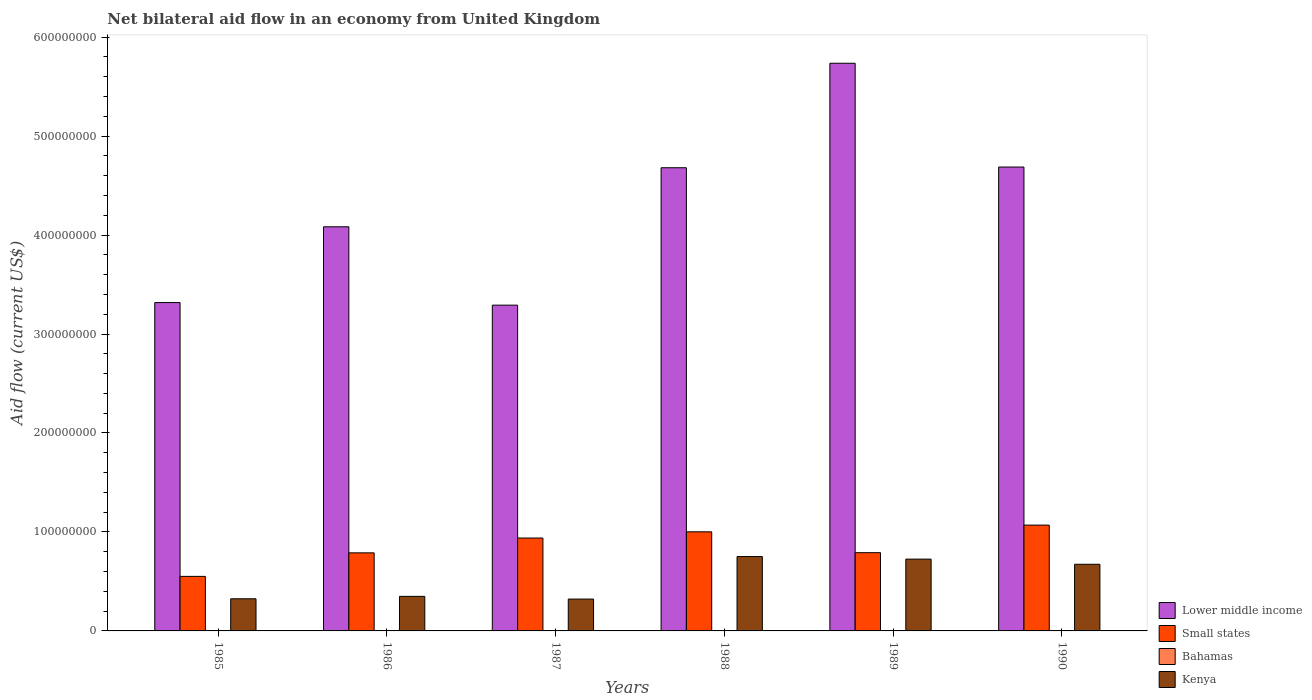How many different coloured bars are there?
Your answer should be very brief. 4. How many bars are there on the 6th tick from the right?
Keep it short and to the point. 4. What is the net bilateral aid flow in Kenya in 1988?
Provide a short and direct response. 7.51e+07. Across all years, what is the maximum net bilateral aid flow in Kenya?
Keep it short and to the point. 7.51e+07. Across all years, what is the minimum net bilateral aid flow in Small states?
Keep it short and to the point. 5.51e+07. In which year was the net bilateral aid flow in Kenya minimum?
Your answer should be compact. 1987. What is the total net bilateral aid flow in Small states in the graph?
Provide a short and direct response. 5.14e+08. What is the difference between the net bilateral aid flow in Lower middle income in 1985 and the net bilateral aid flow in Small states in 1990?
Provide a succinct answer. 2.25e+08. What is the average net bilateral aid flow in Lower middle income per year?
Provide a short and direct response. 4.30e+08. In the year 1988, what is the difference between the net bilateral aid flow in Bahamas and net bilateral aid flow in Small states?
Make the answer very short. -1.00e+08. What is the ratio of the net bilateral aid flow in Lower middle income in 1986 to that in 1987?
Ensure brevity in your answer.  1.24. What is the difference between the highest and the second highest net bilateral aid flow in Lower middle income?
Give a very brief answer. 1.05e+08. What is the difference between the highest and the lowest net bilateral aid flow in Kenya?
Provide a short and direct response. 4.29e+07. In how many years, is the net bilateral aid flow in Small states greater than the average net bilateral aid flow in Small states taken over all years?
Your answer should be compact. 3. Is the sum of the net bilateral aid flow in Lower middle income in 1986 and 1990 greater than the maximum net bilateral aid flow in Small states across all years?
Provide a short and direct response. Yes. What does the 2nd bar from the left in 1989 represents?
Your response must be concise. Small states. What does the 4th bar from the right in 1985 represents?
Give a very brief answer. Lower middle income. Are the values on the major ticks of Y-axis written in scientific E-notation?
Provide a succinct answer. No. Does the graph contain grids?
Your answer should be very brief. No. Where does the legend appear in the graph?
Ensure brevity in your answer.  Bottom right. What is the title of the graph?
Offer a terse response. Net bilateral aid flow in an economy from United Kingdom. What is the label or title of the X-axis?
Your answer should be compact. Years. What is the label or title of the Y-axis?
Keep it short and to the point. Aid flow (current US$). What is the Aid flow (current US$) of Lower middle income in 1985?
Offer a very short reply. 3.32e+08. What is the Aid flow (current US$) of Small states in 1985?
Your response must be concise. 5.51e+07. What is the Aid flow (current US$) in Bahamas in 1985?
Your answer should be very brief. 10000. What is the Aid flow (current US$) in Kenya in 1985?
Your answer should be very brief. 3.25e+07. What is the Aid flow (current US$) of Lower middle income in 1986?
Provide a short and direct response. 4.08e+08. What is the Aid flow (current US$) of Small states in 1986?
Give a very brief answer. 7.89e+07. What is the Aid flow (current US$) in Bahamas in 1986?
Offer a very short reply. 10000. What is the Aid flow (current US$) in Kenya in 1986?
Provide a short and direct response. 3.49e+07. What is the Aid flow (current US$) in Lower middle income in 1987?
Keep it short and to the point. 3.29e+08. What is the Aid flow (current US$) in Small states in 1987?
Ensure brevity in your answer.  9.39e+07. What is the Aid flow (current US$) of Kenya in 1987?
Offer a terse response. 3.22e+07. What is the Aid flow (current US$) in Lower middle income in 1988?
Give a very brief answer. 4.68e+08. What is the Aid flow (current US$) in Small states in 1988?
Your answer should be very brief. 1.00e+08. What is the Aid flow (current US$) of Kenya in 1988?
Give a very brief answer. 7.51e+07. What is the Aid flow (current US$) in Lower middle income in 1989?
Offer a very short reply. 5.74e+08. What is the Aid flow (current US$) in Small states in 1989?
Make the answer very short. 7.91e+07. What is the Aid flow (current US$) of Bahamas in 1989?
Your answer should be compact. 3.00e+04. What is the Aid flow (current US$) in Kenya in 1989?
Provide a succinct answer. 7.26e+07. What is the Aid flow (current US$) in Lower middle income in 1990?
Make the answer very short. 4.69e+08. What is the Aid flow (current US$) in Small states in 1990?
Ensure brevity in your answer.  1.07e+08. What is the Aid flow (current US$) in Kenya in 1990?
Offer a terse response. 6.73e+07. Across all years, what is the maximum Aid flow (current US$) in Lower middle income?
Ensure brevity in your answer.  5.74e+08. Across all years, what is the maximum Aid flow (current US$) of Small states?
Provide a short and direct response. 1.07e+08. Across all years, what is the maximum Aid flow (current US$) of Kenya?
Offer a terse response. 7.51e+07. Across all years, what is the minimum Aid flow (current US$) of Lower middle income?
Keep it short and to the point. 3.29e+08. Across all years, what is the minimum Aid flow (current US$) in Small states?
Your answer should be compact. 5.51e+07. Across all years, what is the minimum Aid flow (current US$) in Kenya?
Offer a very short reply. 3.22e+07. What is the total Aid flow (current US$) in Lower middle income in the graph?
Make the answer very short. 2.58e+09. What is the total Aid flow (current US$) of Small states in the graph?
Offer a terse response. 5.14e+08. What is the total Aid flow (current US$) in Kenya in the graph?
Your answer should be compact. 3.15e+08. What is the difference between the Aid flow (current US$) in Lower middle income in 1985 and that in 1986?
Offer a terse response. -7.66e+07. What is the difference between the Aid flow (current US$) of Small states in 1985 and that in 1986?
Offer a very short reply. -2.38e+07. What is the difference between the Aid flow (current US$) of Kenya in 1985 and that in 1986?
Offer a very short reply. -2.45e+06. What is the difference between the Aid flow (current US$) of Lower middle income in 1985 and that in 1987?
Make the answer very short. 2.61e+06. What is the difference between the Aid flow (current US$) in Small states in 1985 and that in 1987?
Give a very brief answer. -3.88e+07. What is the difference between the Aid flow (current US$) in Kenya in 1985 and that in 1987?
Your response must be concise. 2.90e+05. What is the difference between the Aid flow (current US$) in Lower middle income in 1985 and that in 1988?
Offer a terse response. -1.36e+08. What is the difference between the Aid flow (current US$) in Small states in 1985 and that in 1988?
Give a very brief answer. -4.50e+07. What is the difference between the Aid flow (current US$) in Kenya in 1985 and that in 1988?
Offer a very short reply. -4.26e+07. What is the difference between the Aid flow (current US$) of Lower middle income in 1985 and that in 1989?
Offer a very short reply. -2.42e+08. What is the difference between the Aid flow (current US$) of Small states in 1985 and that in 1989?
Ensure brevity in your answer.  -2.40e+07. What is the difference between the Aid flow (current US$) in Bahamas in 1985 and that in 1989?
Keep it short and to the point. -2.00e+04. What is the difference between the Aid flow (current US$) of Kenya in 1985 and that in 1989?
Your answer should be compact. -4.01e+07. What is the difference between the Aid flow (current US$) in Lower middle income in 1985 and that in 1990?
Keep it short and to the point. -1.37e+08. What is the difference between the Aid flow (current US$) in Small states in 1985 and that in 1990?
Your answer should be very brief. -5.18e+07. What is the difference between the Aid flow (current US$) in Bahamas in 1985 and that in 1990?
Offer a very short reply. -1.30e+05. What is the difference between the Aid flow (current US$) of Kenya in 1985 and that in 1990?
Provide a succinct answer. -3.49e+07. What is the difference between the Aid flow (current US$) in Lower middle income in 1986 and that in 1987?
Your answer should be compact. 7.92e+07. What is the difference between the Aid flow (current US$) of Small states in 1986 and that in 1987?
Keep it short and to the point. -1.50e+07. What is the difference between the Aid flow (current US$) of Kenya in 1986 and that in 1987?
Provide a succinct answer. 2.74e+06. What is the difference between the Aid flow (current US$) of Lower middle income in 1986 and that in 1988?
Your response must be concise. -5.96e+07. What is the difference between the Aid flow (current US$) of Small states in 1986 and that in 1988?
Offer a terse response. -2.12e+07. What is the difference between the Aid flow (current US$) of Bahamas in 1986 and that in 1988?
Ensure brevity in your answer.  0. What is the difference between the Aid flow (current US$) in Kenya in 1986 and that in 1988?
Your response must be concise. -4.02e+07. What is the difference between the Aid flow (current US$) in Lower middle income in 1986 and that in 1989?
Offer a terse response. -1.65e+08. What is the difference between the Aid flow (current US$) in Small states in 1986 and that in 1989?
Offer a very short reply. -1.70e+05. What is the difference between the Aid flow (current US$) in Kenya in 1986 and that in 1989?
Make the answer very short. -3.76e+07. What is the difference between the Aid flow (current US$) of Lower middle income in 1986 and that in 1990?
Offer a terse response. -6.04e+07. What is the difference between the Aid flow (current US$) in Small states in 1986 and that in 1990?
Give a very brief answer. -2.80e+07. What is the difference between the Aid flow (current US$) of Bahamas in 1986 and that in 1990?
Your answer should be very brief. -1.30e+05. What is the difference between the Aid flow (current US$) in Kenya in 1986 and that in 1990?
Give a very brief answer. -3.24e+07. What is the difference between the Aid flow (current US$) in Lower middle income in 1987 and that in 1988?
Offer a very short reply. -1.39e+08. What is the difference between the Aid flow (current US$) in Small states in 1987 and that in 1988?
Your answer should be compact. -6.27e+06. What is the difference between the Aid flow (current US$) in Kenya in 1987 and that in 1988?
Keep it short and to the point. -4.29e+07. What is the difference between the Aid flow (current US$) in Lower middle income in 1987 and that in 1989?
Your answer should be very brief. -2.44e+08. What is the difference between the Aid flow (current US$) of Small states in 1987 and that in 1989?
Give a very brief answer. 1.48e+07. What is the difference between the Aid flow (current US$) in Kenya in 1987 and that in 1989?
Offer a very short reply. -4.04e+07. What is the difference between the Aid flow (current US$) in Lower middle income in 1987 and that in 1990?
Ensure brevity in your answer.  -1.40e+08. What is the difference between the Aid flow (current US$) of Small states in 1987 and that in 1990?
Provide a succinct answer. -1.31e+07. What is the difference between the Aid flow (current US$) of Bahamas in 1987 and that in 1990?
Provide a short and direct response. -1.20e+05. What is the difference between the Aid flow (current US$) of Kenya in 1987 and that in 1990?
Your answer should be very brief. -3.52e+07. What is the difference between the Aid flow (current US$) of Lower middle income in 1988 and that in 1989?
Keep it short and to the point. -1.06e+08. What is the difference between the Aid flow (current US$) of Small states in 1988 and that in 1989?
Ensure brevity in your answer.  2.11e+07. What is the difference between the Aid flow (current US$) in Bahamas in 1988 and that in 1989?
Provide a short and direct response. -2.00e+04. What is the difference between the Aid flow (current US$) of Kenya in 1988 and that in 1989?
Offer a terse response. 2.56e+06. What is the difference between the Aid flow (current US$) in Lower middle income in 1988 and that in 1990?
Make the answer very short. -7.00e+05. What is the difference between the Aid flow (current US$) in Small states in 1988 and that in 1990?
Provide a short and direct response. -6.79e+06. What is the difference between the Aid flow (current US$) in Kenya in 1988 and that in 1990?
Offer a terse response. 7.78e+06. What is the difference between the Aid flow (current US$) of Lower middle income in 1989 and that in 1990?
Give a very brief answer. 1.05e+08. What is the difference between the Aid flow (current US$) in Small states in 1989 and that in 1990?
Your answer should be compact. -2.79e+07. What is the difference between the Aid flow (current US$) of Bahamas in 1989 and that in 1990?
Your answer should be very brief. -1.10e+05. What is the difference between the Aid flow (current US$) in Kenya in 1989 and that in 1990?
Keep it short and to the point. 5.22e+06. What is the difference between the Aid flow (current US$) in Lower middle income in 1985 and the Aid flow (current US$) in Small states in 1986?
Your answer should be compact. 2.53e+08. What is the difference between the Aid flow (current US$) of Lower middle income in 1985 and the Aid flow (current US$) of Bahamas in 1986?
Your answer should be compact. 3.32e+08. What is the difference between the Aid flow (current US$) in Lower middle income in 1985 and the Aid flow (current US$) in Kenya in 1986?
Your answer should be compact. 2.97e+08. What is the difference between the Aid flow (current US$) in Small states in 1985 and the Aid flow (current US$) in Bahamas in 1986?
Your response must be concise. 5.51e+07. What is the difference between the Aid flow (current US$) in Small states in 1985 and the Aid flow (current US$) in Kenya in 1986?
Keep it short and to the point. 2.02e+07. What is the difference between the Aid flow (current US$) in Bahamas in 1985 and the Aid flow (current US$) in Kenya in 1986?
Your answer should be compact. -3.49e+07. What is the difference between the Aid flow (current US$) of Lower middle income in 1985 and the Aid flow (current US$) of Small states in 1987?
Your answer should be compact. 2.38e+08. What is the difference between the Aid flow (current US$) in Lower middle income in 1985 and the Aid flow (current US$) in Bahamas in 1987?
Your response must be concise. 3.32e+08. What is the difference between the Aid flow (current US$) in Lower middle income in 1985 and the Aid flow (current US$) in Kenya in 1987?
Your answer should be compact. 3.00e+08. What is the difference between the Aid flow (current US$) of Small states in 1985 and the Aid flow (current US$) of Bahamas in 1987?
Your answer should be compact. 5.51e+07. What is the difference between the Aid flow (current US$) in Small states in 1985 and the Aid flow (current US$) in Kenya in 1987?
Make the answer very short. 2.29e+07. What is the difference between the Aid flow (current US$) in Bahamas in 1985 and the Aid flow (current US$) in Kenya in 1987?
Provide a short and direct response. -3.22e+07. What is the difference between the Aid flow (current US$) of Lower middle income in 1985 and the Aid flow (current US$) of Small states in 1988?
Your answer should be compact. 2.32e+08. What is the difference between the Aid flow (current US$) in Lower middle income in 1985 and the Aid flow (current US$) in Bahamas in 1988?
Give a very brief answer. 3.32e+08. What is the difference between the Aid flow (current US$) in Lower middle income in 1985 and the Aid flow (current US$) in Kenya in 1988?
Keep it short and to the point. 2.57e+08. What is the difference between the Aid flow (current US$) in Small states in 1985 and the Aid flow (current US$) in Bahamas in 1988?
Give a very brief answer. 5.51e+07. What is the difference between the Aid flow (current US$) in Small states in 1985 and the Aid flow (current US$) in Kenya in 1988?
Offer a terse response. -2.00e+07. What is the difference between the Aid flow (current US$) of Bahamas in 1985 and the Aid flow (current US$) of Kenya in 1988?
Provide a succinct answer. -7.51e+07. What is the difference between the Aid flow (current US$) of Lower middle income in 1985 and the Aid flow (current US$) of Small states in 1989?
Offer a very short reply. 2.53e+08. What is the difference between the Aid flow (current US$) of Lower middle income in 1985 and the Aid flow (current US$) of Bahamas in 1989?
Provide a succinct answer. 3.32e+08. What is the difference between the Aid flow (current US$) in Lower middle income in 1985 and the Aid flow (current US$) in Kenya in 1989?
Provide a short and direct response. 2.59e+08. What is the difference between the Aid flow (current US$) of Small states in 1985 and the Aid flow (current US$) of Bahamas in 1989?
Your answer should be compact. 5.51e+07. What is the difference between the Aid flow (current US$) in Small states in 1985 and the Aid flow (current US$) in Kenya in 1989?
Give a very brief answer. -1.75e+07. What is the difference between the Aid flow (current US$) of Bahamas in 1985 and the Aid flow (current US$) of Kenya in 1989?
Your answer should be very brief. -7.26e+07. What is the difference between the Aid flow (current US$) in Lower middle income in 1985 and the Aid flow (current US$) in Small states in 1990?
Your response must be concise. 2.25e+08. What is the difference between the Aid flow (current US$) in Lower middle income in 1985 and the Aid flow (current US$) in Bahamas in 1990?
Offer a very short reply. 3.32e+08. What is the difference between the Aid flow (current US$) of Lower middle income in 1985 and the Aid flow (current US$) of Kenya in 1990?
Your response must be concise. 2.64e+08. What is the difference between the Aid flow (current US$) in Small states in 1985 and the Aid flow (current US$) in Bahamas in 1990?
Offer a terse response. 5.50e+07. What is the difference between the Aid flow (current US$) in Small states in 1985 and the Aid flow (current US$) in Kenya in 1990?
Your answer should be compact. -1.22e+07. What is the difference between the Aid flow (current US$) of Bahamas in 1985 and the Aid flow (current US$) of Kenya in 1990?
Your response must be concise. -6.73e+07. What is the difference between the Aid flow (current US$) in Lower middle income in 1986 and the Aid flow (current US$) in Small states in 1987?
Give a very brief answer. 3.14e+08. What is the difference between the Aid flow (current US$) of Lower middle income in 1986 and the Aid flow (current US$) of Bahamas in 1987?
Your answer should be compact. 4.08e+08. What is the difference between the Aid flow (current US$) in Lower middle income in 1986 and the Aid flow (current US$) in Kenya in 1987?
Your answer should be very brief. 3.76e+08. What is the difference between the Aid flow (current US$) in Small states in 1986 and the Aid flow (current US$) in Bahamas in 1987?
Offer a terse response. 7.89e+07. What is the difference between the Aid flow (current US$) in Small states in 1986 and the Aid flow (current US$) in Kenya in 1987?
Give a very brief answer. 4.67e+07. What is the difference between the Aid flow (current US$) of Bahamas in 1986 and the Aid flow (current US$) of Kenya in 1987?
Offer a very short reply. -3.22e+07. What is the difference between the Aid flow (current US$) in Lower middle income in 1986 and the Aid flow (current US$) in Small states in 1988?
Your response must be concise. 3.08e+08. What is the difference between the Aid flow (current US$) of Lower middle income in 1986 and the Aid flow (current US$) of Bahamas in 1988?
Your answer should be very brief. 4.08e+08. What is the difference between the Aid flow (current US$) of Lower middle income in 1986 and the Aid flow (current US$) of Kenya in 1988?
Your answer should be very brief. 3.33e+08. What is the difference between the Aid flow (current US$) of Small states in 1986 and the Aid flow (current US$) of Bahamas in 1988?
Your answer should be compact. 7.89e+07. What is the difference between the Aid flow (current US$) in Small states in 1986 and the Aid flow (current US$) in Kenya in 1988?
Make the answer very short. 3.77e+06. What is the difference between the Aid flow (current US$) in Bahamas in 1986 and the Aid flow (current US$) in Kenya in 1988?
Make the answer very short. -7.51e+07. What is the difference between the Aid flow (current US$) of Lower middle income in 1986 and the Aid flow (current US$) of Small states in 1989?
Give a very brief answer. 3.29e+08. What is the difference between the Aid flow (current US$) of Lower middle income in 1986 and the Aid flow (current US$) of Bahamas in 1989?
Ensure brevity in your answer.  4.08e+08. What is the difference between the Aid flow (current US$) of Lower middle income in 1986 and the Aid flow (current US$) of Kenya in 1989?
Offer a very short reply. 3.36e+08. What is the difference between the Aid flow (current US$) of Small states in 1986 and the Aid flow (current US$) of Bahamas in 1989?
Your answer should be compact. 7.89e+07. What is the difference between the Aid flow (current US$) in Small states in 1986 and the Aid flow (current US$) in Kenya in 1989?
Your answer should be very brief. 6.33e+06. What is the difference between the Aid flow (current US$) in Bahamas in 1986 and the Aid flow (current US$) in Kenya in 1989?
Your answer should be very brief. -7.26e+07. What is the difference between the Aid flow (current US$) in Lower middle income in 1986 and the Aid flow (current US$) in Small states in 1990?
Make the answer very short. 3.01e+08. What is the difference between the Aid flow (current US$) of Lower middle income in 1986 and the Aid flow (current US$) of Bahamas in 1990?
Give a very brief answer. 4.08e+08. What is the difference between the Aid flow (current US$) of Lower middle income in 1986 and the Aid flow (current US$) of Kenya in 1990?
Make the answer very short. 3.41e+08. What is the difference between the Aid flow (current US$) in Small states in 1986 and the Aid flow (current US$) in Bahamas in 1990?
Make the answer very short. 7.88e+07. What is the difference between the Aid flow (current US$) in Small states in 1986 and the Aid flow (current US$) in Kenya in 1990?
Ensure brevity in your answer.  1.16e+07. What is the difference between the Aid flow (current US$) of Bahamas in 1986 and the Aid flow (current US$) of Kenya in 1990?
Your answer should be very brief. -6.73e+07. What is the difference between the Aid flow (current US$) of Lower middle income in 1987 and the Aid flow (current US$) of Small states in 1988?
Ensure brevity in your answer.  2.29e+08. What is the difference between the Aid flow (current US$) of Lower middle income in 1987 and the Aid flow (current US$) of Bahamas in 1988?
Offer a terse response. 3.29e+08. What is the difference between the Aid flow (current US$) of Lower middle income in 1987 and the Aid flow (current US$) of Kenya in 1988?
Provide a succinct answer. 2.54e+08. What is the difference between the Aid flow (current US$) of Small states in 1987 and the Aid flow (current US$) of Bahamas in 1988?
Your answer should be very brief. 9.38e+07. What is the difference between the Aid flow (current US$) in Small states in 1987 and the Aid flow (current US$) in Kenya in 1988?
Keep it short and to the point. 1.87e+07. What is the difference between the Aid flow (current US$) in Bahamas in 1987 and the Aid flow (current US$) in Kenya in 1988?
Offer a terse response. -7.51e+07. What is the difference between the Aid flow (current US$) in Lower middle income in 1987 and the Aid flow (current US$) in Small states in 1989?
Offer a very short reply. 2.50e+08. What is the difference between the Aid flow (current US$) of Lower middle income in 1987 and the Aid flow (current US$) of Bahamas in 1989?
Your response must be concise. 3.29e+08. What is the difference between the Aid flow (current US$) of Lower middle income in 1987 and the Aid flow (current US$) of Kenya in 1989?
Your answer should be very brief. 2.57e+08. What is the difference between the Aid flow (current US$) of Small states in 1987 and the Aid flow (current US$) of Bahamas in 1989?
Offer a terse response. 9.38e+07. What is the difference between the Aid flow (current US$) of Small states in 1987 and the Aid flow (current US$) of Kenya in 1989?
Your answer should be very brief. 2.13e+07. What is the difference between the Aid flow (current US$) of Bahamas in 1987 and the Aid flow (current US$) of Kenya in 1989?
Your answer should be very brief. -7.25e+07. What is the difference between the Aid flow (current US$) in Lower middle income in 1987 and the Aid flow (current US$) in Small states in 1990?
Offer a very short reply. 2.22e+08. What is the difference between the Aid flow (current US$) of Lower middle income in 1987 and the Aid flow (current US$) of Bahamas in 1990?
Ensure brevity in your answer.  3.29e+08. What is the difference between the Aid flow (current US$) of Lower middle income in 1987 and the Aid flow (current US$) of Kenya in 1990?
Provide a short and direct response. 2.62e+08. What is the difference between the Aid flow (current US$) in Small states in 1987 and the Aid flow (current US$) in Bahamas in 1990?
Keep it short and to the point. 9.37e+07. What is the difference between the Aid flow (current US$) of Small states in 1987 and the Aid flow (current US$) of Kenya in 1990?
Your answer should be very brief. 2.65e+07. What is the difference between the Aid flow (current US$) in Bahamas in 1987 and the Aid flow (current US$) in Kenya in 1990?
Your answer should be compact. -6.73e+07. What is the difference between the Aid flow (current US$) of Lower middle income in 1988 and the Aid flow (current US$) of Small states in 1989?
Your answer should be very brief. 3.89e+08. What is the difference between the Aid flow (current US$) of Lower middle income in 1988 and the Aid flow (current US$) of Bahamas in 1989?
Your response must be concise. 4.68e+08. What is the difference between the Aid flow (current US$) of Lower middle income in 1988 and the Aid flow (current US$) of Kenya in 1989?
Your answer should be very brief. 3.95e+08. What is the difference between the Aid flow (current US$) in Small states in 1988 and the Aid flow (current US$) in Bahamas in 1989?
Your answer should be very brief. 1.00e+08. What is the difference between the Aid flow (current US$) of Small states in 1988 and the Aid flow (current US$) of Kenya in 1989?
Your answer should be compact. 2.76e+07. What is the difference between the Aid flow (current US$) in Bahamas in 1988 and the Aid flow (current US$) in Kenya in 1989?
Your answer should be compact. -7.26e+07. What is the difference between the Aid flow (current US$) in Lower middle income in 1988 and the Aid flow (current US$) in Small states in 1990?
Give a very brief answer. 3.61e+08. What is the difference between the Aid flow (current US$) of Lower middle income in 1988 and the Aid flow (current US$) of Bahamas in 1990?
Your response must be concise. 4.68e+08. What is the difference between the Aid flow (current US$) in Lower middle income in 1988 and the Aid flow (current US$) in Kenya in 1990?
Provide a succinct answer. 4.01e+08. What is the difference between the Aid flow (current US$) of Small states in 1988 and the Aid flow (current US$) of Bahamas in 1990?
Offer a terse response. 1.00e+08. What is the difference between the Aid flow (current US$) of Small states in 1988 and the Aid flow (current US$) of Kenya in 1990?
Make the answer very short. 3.28e+07. What is the difference between the Aid flow (current US$) of Bahamas in 1988 and the Aid flow (current US$) of Kenya in 1990?
Offer a very short reply. -6.73e+07. What is the difference between the Aid flow (current US$) in Lower middle income in 1989 and the Aid flow (current US$) in Small states in 1990?
Provide a succinct answer. 4.67e+08. What is the difference between the Aid flow (current US$) of Lower middle income in 1989 and the Aid flow (current US$) of Bahamas in 1990?
Your response must be concise. 5.73e+08. What is the difference between the Aid flow (current US$) in Lower middle income in 1989 and the Aid flow (current US$) in Kenya in 1990?
Offer a terse response. 5.06e+08. What is the difference between the Aid flow (current US$) of Small states in 1989 and the Aid flow (current US$) of Bahamas in 1990?
Ensure brevity in your answer.  7.89e+07. What is the difference between the Aid flow (current US$) in Small states in 1989 and the Aid flow (current US$) in Kenya in 1990?
Your answer should be very brief. 1.17e+07. What is the difference between the Aid flow (current US$) in Bahamas in 1989 and the Aid flow (current US$) in Kenya in 1990?
Provide a succinct answer. -6.73e+07. What is the average Aid flow (current US$) in Lower middle income per year?
Make the answer very short. 4.30e+08. What is the average Aid flow (current US$) of Small states per year?
Keep it short and to the point. 8.57e+07. What is the average Aid flow (current US$) of Bahamas per year?
Give a very brief answer. 3.67e+04. What is the average Aid flow (current US$) in Kenya per year?
Your response must be concise. 5.24e+07. In the year 1985, what is the difference between the Aid flow (current US$) of Lower middle income and Aid flow (current US$) of Small states?
Provide a short and direct response. 2.77e+08. In the year 1985, what is the difference between the Aid flow (current US$) in Lower middle income and Aid flow (current US$) in Bahamas?
Make the answer very short. 3.32e+08. In the year 1985, what is the difference between the Aid flow (current US$) of Lower middle income and Aid flow (current US$) of Kenya?
Your response must be concise. 2.99e+08. In the year 1985, what is the difference between the Aid flow (current US$) in Small states and Aid flow (current US$) in Bahamas?
Give a very brief answer. 5.51e+07. In the year 1985, what is the difference between the Aid flow (current US$) of Small states and Aid flow (current US$) of Kenya?
Provide a short and direct response. 2.26e+07. In the year 1985, what is the difference between the Aid flow (current US$) in Bahamas and Aid flow (current US$) in Kenya?
Make the answer very short. -3.25e+07. In the year 1986, what is the difference between the Aid flow (current US$) of Lower middle income and Aid flow (current US$) of Small states?
Offer a terse response. 3.29e+08. In the year 1986, what is the difference between the Aid flow (current US$) of Lower middle income and Aid flow (current US$) of Bahamas?
Ensure brevity in your answer.  4.08e+08. In the year 1986, what is the difference between the Aid flow (current US$) of Lower middle income and Aid flow (current US$) of Kenya?
Offer a very short reply. 3.73e+08. In the year 1986, what is the difference between the Aid flow (current US$) of Small states and Aid flow (current US$) of Bahamas?
Give a very brief answer. 7.89e+07. In the year 1986, what is the difference between the Aid flow (current US$) in Small states and Aid flow (current US$) in Kenya?
Make the answer very short. 4.40e+07. In the year 1986, what is the difference between the Aid flow (current US$) of Bahamas and Aid flow (current US$) of Kenya?
Provide a succinct answer. -3.49e+07. In the year 1987, what is the difference between the Aid flow (current US$) of Lower middle income and Aid flow (current US$) of Small states?
Your answer should be compact. 2.35e+08. In the year 1987, what is the difference between the Aid flow (current US$) of Lower middle income and Aid flow (current US$) of Bahamas?
Offer a terse response. 3.29e+08. In the year 1987, what is the difference between the Aid flow (current US$) of Lower middle income and Aid flow (current US$) of Kenya?
Your answer should be very brief. 2.97e+08. In the year 1987, what is the difference between the Aid flow (current US$) of Small states and Aid flow (current US$) of Bahamas?
Provide a succinct answer. 9.38e+07. In the year 1987, what is the difference between the Aid flow (current US$) in Small states and Aid flow (current US$) in Kenya?
Your response must be concise. 6.17e+07. In the year 1987, what is the difference between the Aid flow (current US$) of Bahamas and Aid flow (current US$) of Kenya?
Your answer should be compact. -3.22e+07. In the year 1988, what is the difference between the Aid flow (current US$) in Lower middle income and Aid flow (current US$) in Small states?
Offer a very short reply. 3.68e+08. In the year 1988, what is the difference between the Aid flow (current US$) in Lower middle income and Aid flow (current US$) in Bahamas?
Make the answer very short. 4.68e+08. In the year 1988, what is the difference between the Aid flow (current US$) of Lower middle income and Aid flow (current US$) of Kenya?
Offer a terse response. 3.93e+08. In the year 1988, what is the difference between the Aid flow (current US$) in Small states and Aid flow (current US$) in Bahamas?
Provide a succinct answer. 1.00e+08. In the year 1988, what is the difference between the Aid flow (current US$) in Small states and Aid flow (current US$) in Kenya?
Provide a succinct answer. 2.50e+07. In the year 1988, what is the difference between the Aid flow (current US$) of Bahamas and Aid flow (current US$) of Kenya?
Your response must be concise. -7.51e+07. In the year 1989, what is the difference between the Aid flow (current US$) of Lower middle income and Aid flow (current US$) of Small states?
Your response must be concise. 4.95e+08. In the year 1989, what is the difference between the Aid flow (current US$) of Lower middle income and Aid flow (current US$) of Bahamas?
Keep it short and to the point. 5.74e+08. In the year 1989, what is the difference between the Aid flow (current US$) in Lower middle income and Aid flow (current US$) in Kenya?
Provide a short and direct response. 5.01e+08. In the year 1989, what is the difference between the Aid flow (current US$) in Small states and Aid flow (current US$) in Bahamas?
Ensure brevity in your answer.  7.90e+07. In the year 1989, what is the difference between the Aid flow (current US$) in Small states and Aid flow (current US$) in Kenya?
Give a very brief answer. 6.50e+06. In the year 1989, what is the difference between the Aid flow (current US$) of Bahamas and Aid flow (current US$) of Kenya?
Provide a succinct answer. -7.25e+07. In the year 1990, what is the difference between the Aid flow (current US$) in Lower middle income and Aid flow (current US$) in Small states?
Your answer should be very brief. 3.62e+08. In the year 1990, what is the difference between the Aid flow (current US$) in Lower middle income and Aid flow (current US$) in Bahamas?
Your response must be concise. 4.69e+08. In the year 1990, what is the difference between the Aid flow (current US$) of Lower middle income and Aid flow (current US$) of Kenya?
Offer a terse response. 4.01e+08. In the year 1990, what is the difference between the Aid flow (current US$) in Small states and Aid flow (current US$) in Bahamas?
Keep it short and to the point. 1.07e+08. In the year 1990, what is the difference between the Aid flow (current US$) of Small states and Aid flow (current US$) of Kenya?
Provide a succinct answer. 3.96e+07. In the year 1990, what is the difference between the Aid flow (current US$) in Bahamas and Aid flow (current US$) in Kenya?
Your response must be concise. -6.72e+07. What is the ratio of the Aid flow (current US$) of Lower middle income in 1985 to that in 1986?
Provide a succinct answer. 0.81. What is the ratio of the Aid flow (current US$) in Small states in 1985 to that in 1986?
Make the answer very short. 0.7. What is the ratio of the Aid flow (current US$) in Kenya in 1985 to that in 1986?
Ensure brevity in your answer.  0.93. What is the ratio of the Aid flow (current US$) in Lower middle income in 1985 to that in 1987?
Your response must be concise. 1.01. What is the ratio of the Aid flow (current US$) of Small states in 1985 to that in 1987?
Offer a terse response. 0.59. What is the ratio of the Aid flow (current US$) of Bahamas in 1985 to that in 1987?
Provide a succinct answer. 0.5. What is the ratio of the Aid flow (current US$) of Kenya in 1985 to that in 1987?
Ensure brevity in your answer.  1.01. What is the ratio of the Aid flow (current US$) of Lower middle income in 1985 to that in 1988?
Make the answer very short. 0.71. What is the ratio of the Aid flow (current US$) of Small states in 1985 to that in 1988?
Offer a very short reply. 0.55. What is the ratio of the Aid flow (current US$) of Bahamas in 1985 to that in 1988?
Make the answer very short. 1. What is the ratio of the Aid flow (current US$) in Kenya in 1985 to that in 1988?
Provide a succinct answer. 0.43. What is the ratio of the Aid flow (current US$) of Lower middle income in 1985 to that in 1989?
Offer a very short reply. 0.58. What is the ratio of the Aid flow (current US$) in Small states in 1985 to that in 1989?
Offer a terse response. 0.7. What is the ratio of the Aid flow (current US$) of Kenya in 1985 to that in 1989?
Your answer should be compact. 0.45. What is the ratio of the Aid flow (current US$) in Lower middle income in 1985 to that in 1990?
Your answer should be very brief. 0.71. What is the ratio of the Aid flow (current US$) of Small states in 1985 to that in 1990?
Provide a succinct answer. 0.52. What is the ratio of the Aid flow (current US$) of Bahamas in 1985 to that in 1990?
Your answer should be compact. 0.07. What is the ratio of the Aid flow (current US$) in Kenya in 1985 to that in 1990?
Your answer should be compact. 0.48. What is the ratio of the Aid flow (current US$) in Lower middle income in 1986 to that in 1987?
Your response must be concise. 1.24. What is the ratio of the Aid flow (current US$) of Small states in 1986 to that in 1987?
Keep it short and to the point. 0.84. What is the ratio of the Aid flow (current US$) in Bahamas in 1986 to that in 1987?
Make the answer very short. 0.5. What is the ratio of the Aid flow (current US$) in Kenya in 1986 to that in 1987?
Keep it short and to the point. 1.09. What is the ratio of the Aid flow (current US$) in Lower middle income in 1986 to that in 1988?
Keep it short and to the point. 0.87. What is the ratio of the Aid flow (current US$) of Small states in 1986 to that in 1988?
Give a very brief answer. 0.79. What is the ratio of the Aid flow (current US$) in Kenya in 1986 to that in 1988?
Your response must be concise. 0.46. What is the ratio of the Aid flow (current US$) in Lower middle income in 1986 to that in 1989?
Offer a very short reply. 0.71. What is the ratio of the Aid flow (current US$) of Small states in 1986 to that in 1989?
Keep it short and to the point. 1. What is the ratio of the Aid flow (current US$) in Kenya in 1986 to that in 1989?
Keep it short and to the point. 0.48. What is the ratio of the Aid flow (current US$) in Lower middle income in 1986 to that in 1990?
Make the answer very short. 0.87. What is the ratio of the Aid flow (current US$) in Small states in 1986 to that in 1990?
Your answer should be very brief. 0.74. What is the ratio of the Aid flow (current US$) in Bahamas in 1986 to that in 1990?
Your answer should be very brief. 0.07. What is the ratio of the Aid flow (current US$) in Kenya in 1986 to that in 1990?
Your answer should be compact. 0.52. What is the ratio of the Aid flow (current US$) in Lower middle income in 1987 to that in 1988?
Your answer should be compact. 0.7. What is the ratio of the Aid flow (current US$) in Small states in 1987 to that in 1988?
Keep it short and to the point. 0.94. What is the ratio of the Aid flow (current US$) of Kenya in 1987 to that in 1988?
Your answer should be very brief. 0.43. What is the ratio of the Aid flow (current US$) of Lower middle income in 1987 to that in 1989?
Give a very brief answer. 0.57. What is the ratio of the Aid flow (current US$) in Small states in 1987 to that in 1989?
Your response must be concise. 1.19. What is the ratio of the Aid flow (current US$) of Bahamas in 1987 to that in 1989?
Make the answer very short. 0.67. What is the ratio of the Aid flow (current US$) in Kenya in 1987 to that in 1989?
Provide a succinct answer. 0.44. What is the ratio of the Aid flow (current US$) in Lower middle income in 1987 to that in 1990?
Your answer should be compact. 0.7. What is the ratio of the Aid flow (current US$) of Small states in 1987 to that in 1990?
Your answer should be very brief. 0.88. What is the ratio of the Aid flow (current US$) in Bahamas in 1987 to that in 1990?
Offer a terse response. 0.14. What is the ratio of the Aid flow (current US$) in Kenya in 1987 to that in 1990?
Offer a terse response. 0.48. What is the ratio of the Aid flow (current US$) of Lower middle income in 1988 to that in 1989?
Ensure brevity in your answer.  0.82. What is the ratio of the Aid flow (current US$) in Small states in 1988 to that in 1989?
Offer a very short reply. 1.27. What is the ratio of the Aid flow (current US$) of Bahamas in 1988 to that in 1989?
Make the answer very short. 0.33. What is the ratio of the Aid flow (current US$) in Kenya in 1988 to that in 1989?
Ensure brevity in your answer.  1.04. What is the ratio of the Aid flow (current US$) in Lower middle income in 1988 to that in 1990?
Your answer should be very brief. 1. What is the ratio of the Aid flow (current US$) in Small states in 1988 to that in 1990?
Offer a very short reply. 0.94. What is the ratio of the Aid flow (current US$) of Bahamas in 1988 to that in 1990?
Provide a succinct answer. 0.07. What is the ratio of the Aid flow (current US$) in Kenya in 1988 to that in 1990?
Make the answer very short. 1.12. What is the ratio of the Aid flow (current US$) of Lower middle income in 1989 to that in 1990?
Provide a short and direct response. 1.22. What is the ratio of the Aid flow (current US$) in Small states in 1989 to that in 1990?
Provide a succinct answer. 0.74. What is the ratio of the Aid flow (current US$) of Bahamas in 1989 to that in 1990?
Provide a succinct answer. 0.21. What is the ratio of the Aid flow (current US$) in Kenya in 1989 to that in 1990?
Give a very brief answer. 1.08. What is the difference between the highest and the second highest Aid flow (current US$) of Lower middle income?
Give a very brief answer. 1.05e+08. What is the difference between the highest and the second highest Aid flow (current US$) in Small states?
Provide a succinct answer. 6.79e+06. What is the difference between the highest and the second highest Aid flow (current US$) of Bahamas?
Offer a very short reply. 1.10e+05. What is the difference between the highest and the second highest Aid flow (current US$) in Kenya?
Offer a terse response. 2.56e+06. What is the difference between the highest and the lowest Aid flow (current US$) of Lower middle income?
Your answer should be compact. 2.44e+08. What is the difference between the highest and the lowest Aid flow (current US$) of Small states?
Provide a succinct answer. 5.18e+07. What is the difference between the highest and the lowest Aid flow (current US$) in Bahamas?
Keep it short and to the point. 1.30e+05. What is the difference between the highest and the lowest Aid flow (current US$) in Kenya?
Make the answer very short. 4.29e+07. 